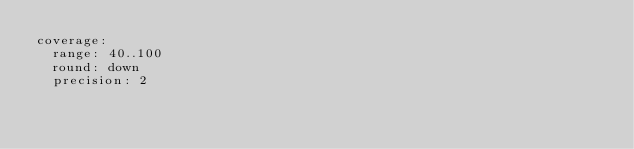Convert code to text. <code><loc_0><loc_0><loc_500><loc_500><_YAML_>coverage:
  range: 40..100
  round: down
  precision: 2
</code> 